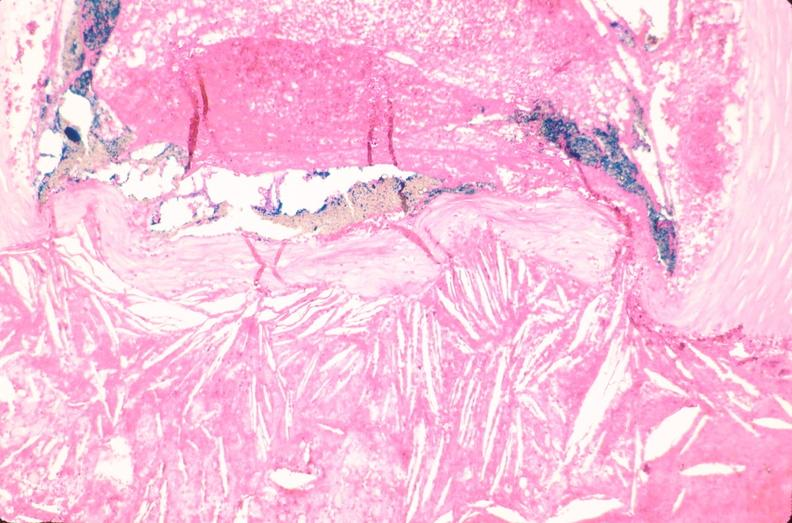s vasculature present?
Answer the question using a single word or phrase. Yes 